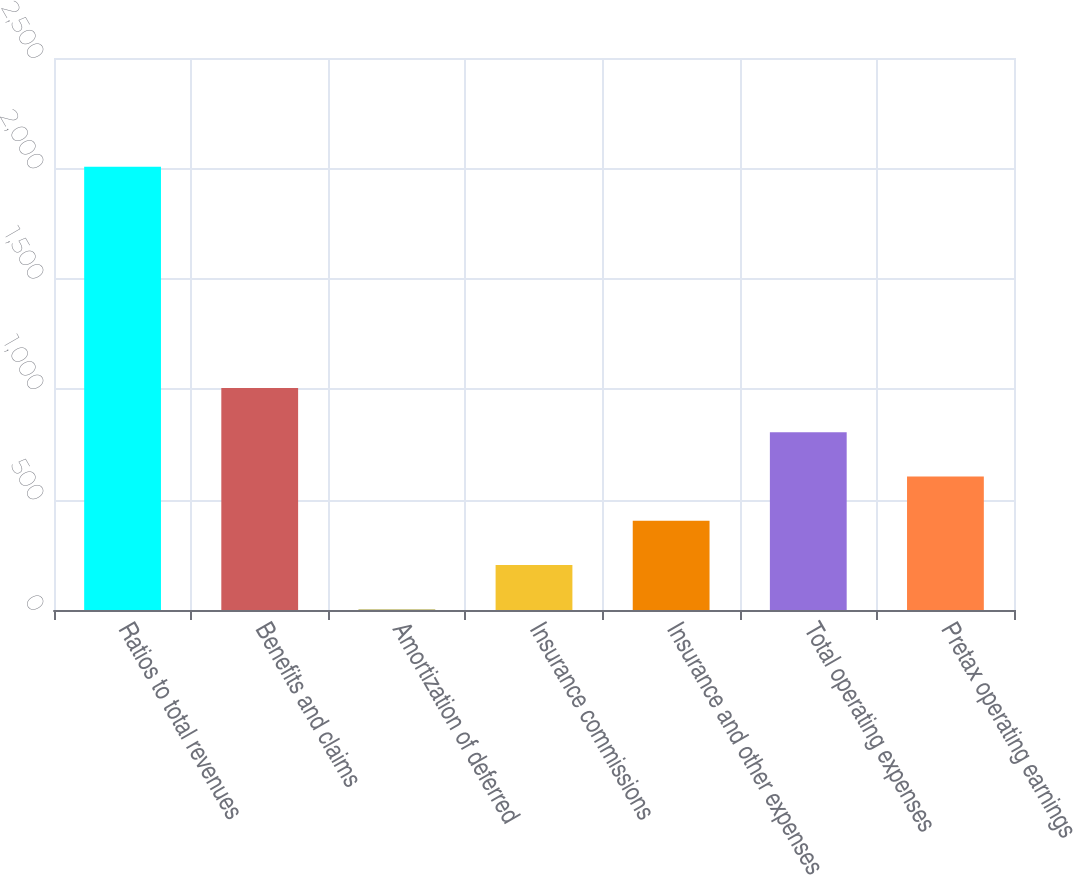<chart> <loc_0><loc_0><loc_500><loc_500><bar_chart><fcel>Ratios to total revenues<fcel>Benefits and claims<fcel>Amortization of deferred<fcel>Insurance commissions<fcel>Insurance and other expenses<fcel>Total operating expenses<fcel>Pretax operating earnings<nl><fcel>2007<fcel>1004.95<fcel>2.9<fcel>203.31<fcel>403.72<fcel>804.54<fcel>604.13<nl></chart> 